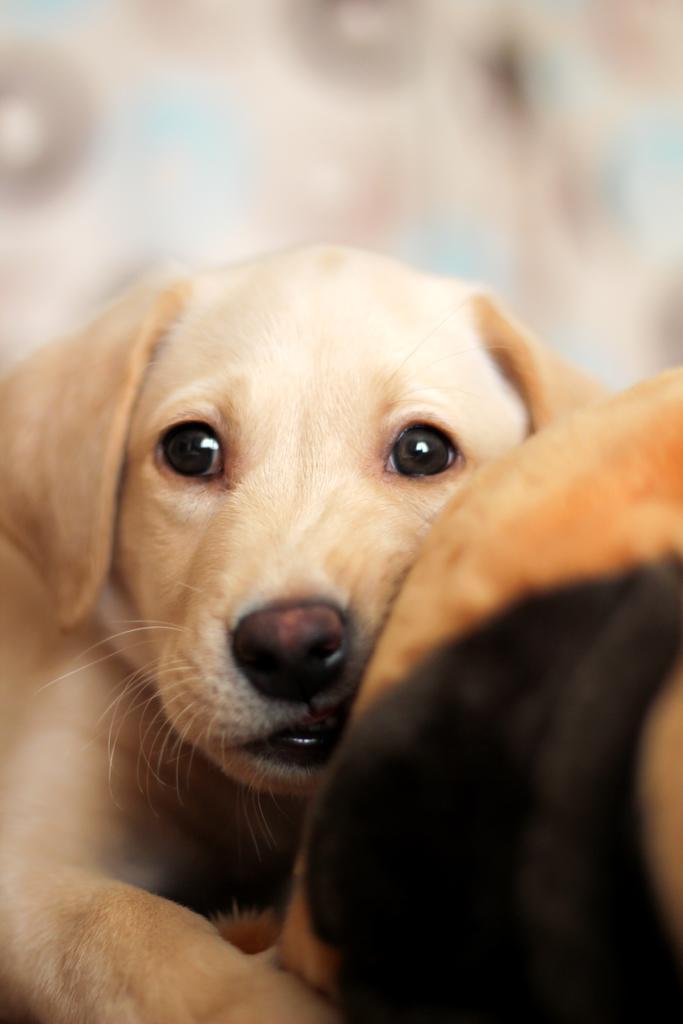Please provide a concise description of this image. There is a white dog. In the background it is blurred. 